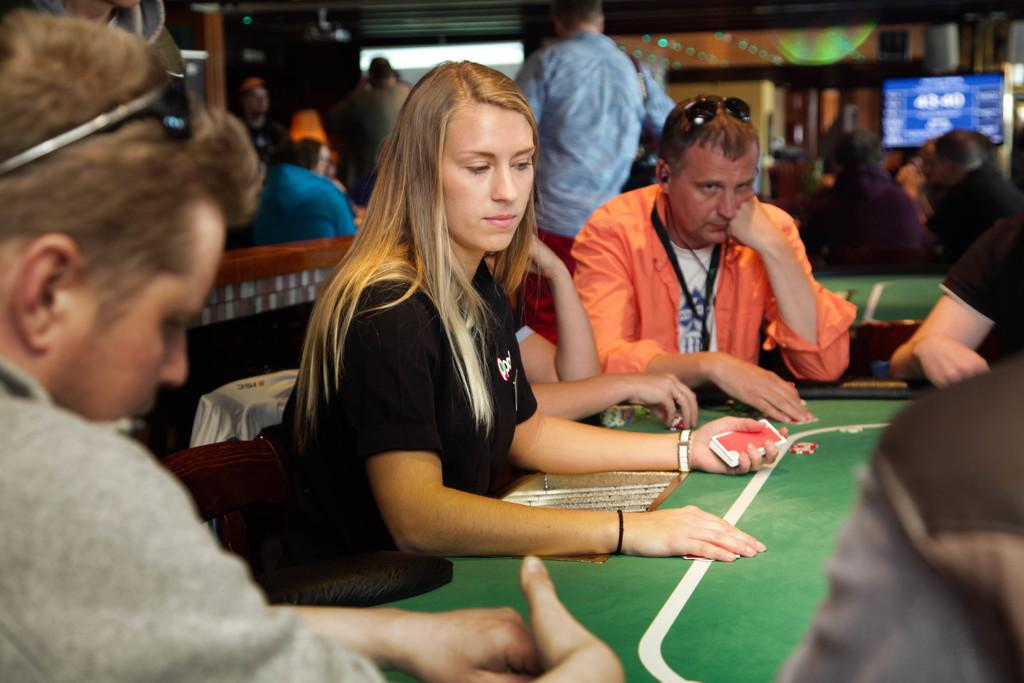What is happening at the table in the image? There are people at the table, and a woman is holding cards in her hand. Can you describe the people behind the table? There are people behind the table, but their actions or appearance cannot be determined from the provided facts. What is the purpose of the screen visible in the image? The purpose of the screen cannot be determined from the provided facts. What type of paste is being used by the people at the table? There is no mention of paste in the image, so it cannot be determined if any paste is being used. What caused the people to gather at the table? The cause of the gathering cannot be determined from the provided facts. 